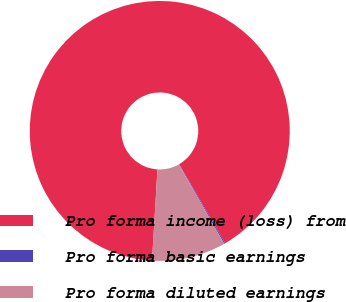Convert chart to OTSL. <chart><loc_0><loc_0><loc_500><loc_500><pie_chart><fcel>Pro forma income (loss) from<fcel>Pro forma basic earnings<fcel>Pro forma diluted earnings<nl><fcel>90.65%<fcel>0.15%<fcel>9.2%<nl></chart> 